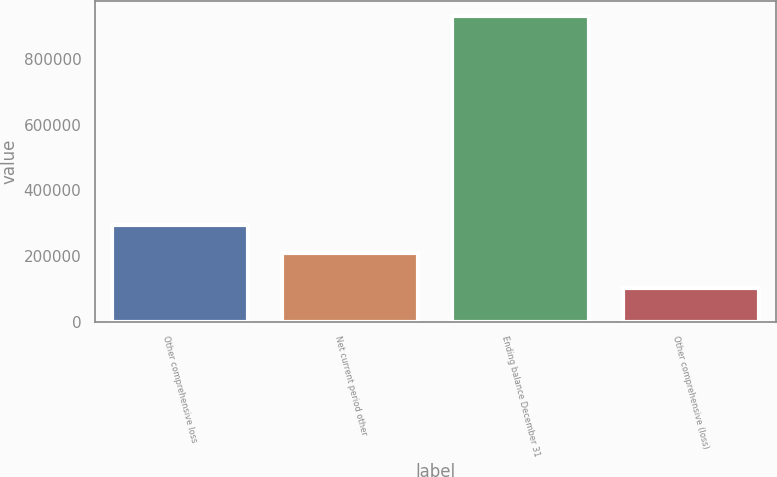Convert chart. <chart><loc_0><loc_0><loc_500><loc_500><bar_chart><fcel>Other comprehensive loss<fcel>Net current period other<fcel>Ending balance December 31<fcel>Other comprehensive (loss)<nl><fcel>293299<fcel>210407<fcel>930618<fcel>101700<nl></chart> 